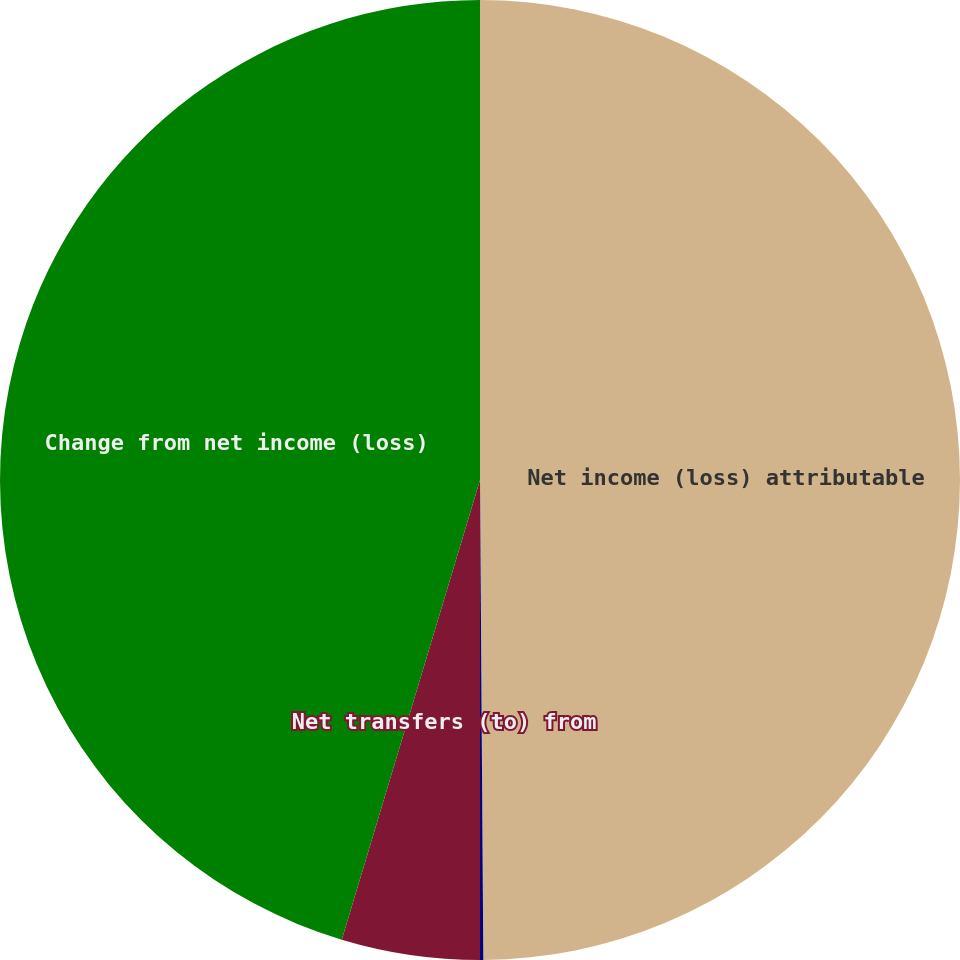Convert chart to OTSL. <chart><loc_0><loc_0><loc_500><loc_500><pie_chart><fcel>Net income (loss) attributable<fcel>Increase (decrease) in The AES<fcel>Net transfers (to) from<fcel>Change from net income (loss)<nl><fcel>49.89%<fcel>0.11%<fcel>4.65%<fcel>45.35%<nl></chart> 